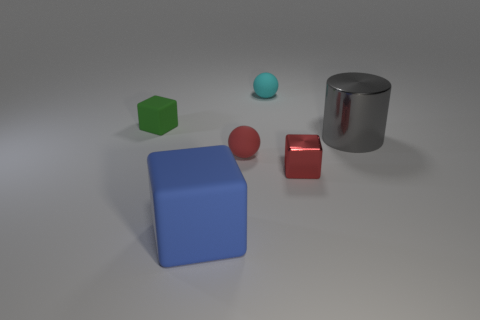Are the cylinder and the small cube that is in front of the small green block made of the same material?
Offer a terse response. Yes. There is a tiny sphere that is to the left of the thing behind the green thing; what is its color?
Offer a very short reply. Red. What is the size of the block that is to the left of the metallic block and in front of the big cylinder?
Your response must be concise. Large. What number of other things are there of the same shape as the tiny red matte object?
Offer a very short reply. 1. There is a large matte object; is its shape the same as the metallic thing that is on the left side of the metal cylinder?
Offer a terse response. Yes. How many green rubber objects are behind the big gray object?
Give a very brief answer. 1. There is a big thing that is to the left of the cyan rubber thing; is its shape the same as the green object?
Your response must be concise. Yes. What is the color of the cube that is in front of the red cube?
Your answer should be very brief. Blue. The cyan thing that is made of the same material as the red ball is what shape?
Provide a succinct answer. Sphere. Is there anything else that is the same color as the cylinder?
Your answer should be compact. No. 